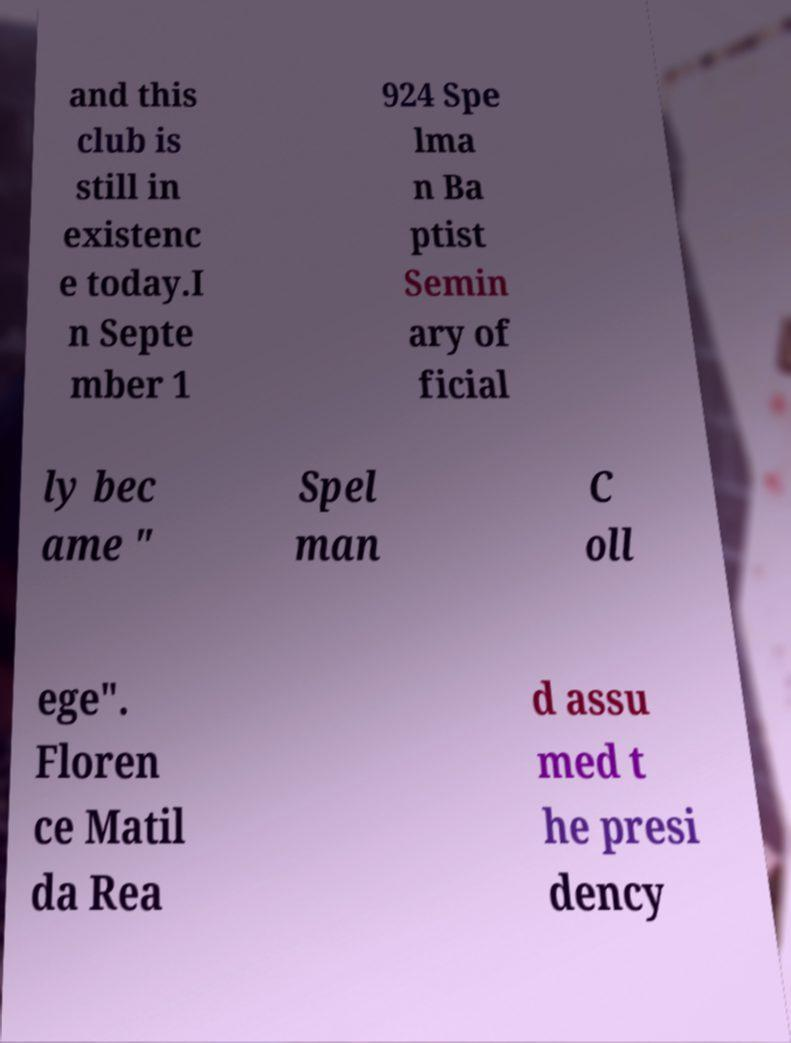Can you accurately transcribe the text from the provided image for me? and this club is still in existenc e today.I n Septe mber 1 924 Spe lma n Ba ptist Semin ary of ficial ly bec ame " Spel man C oll ege". Floren ce Matil da Rea d assu med t he presi dency 